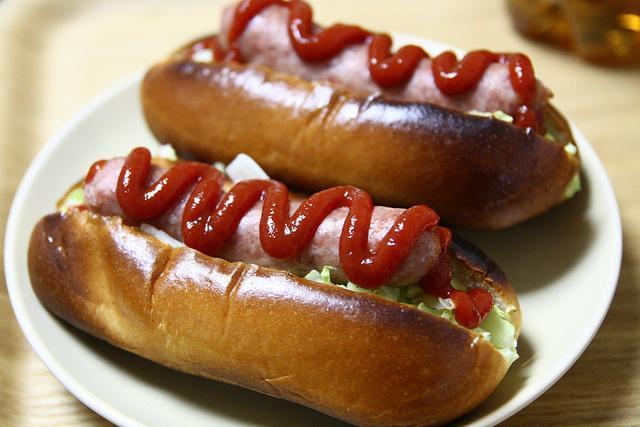How many hot dogs are there?
Give a very brief answer. 2. 